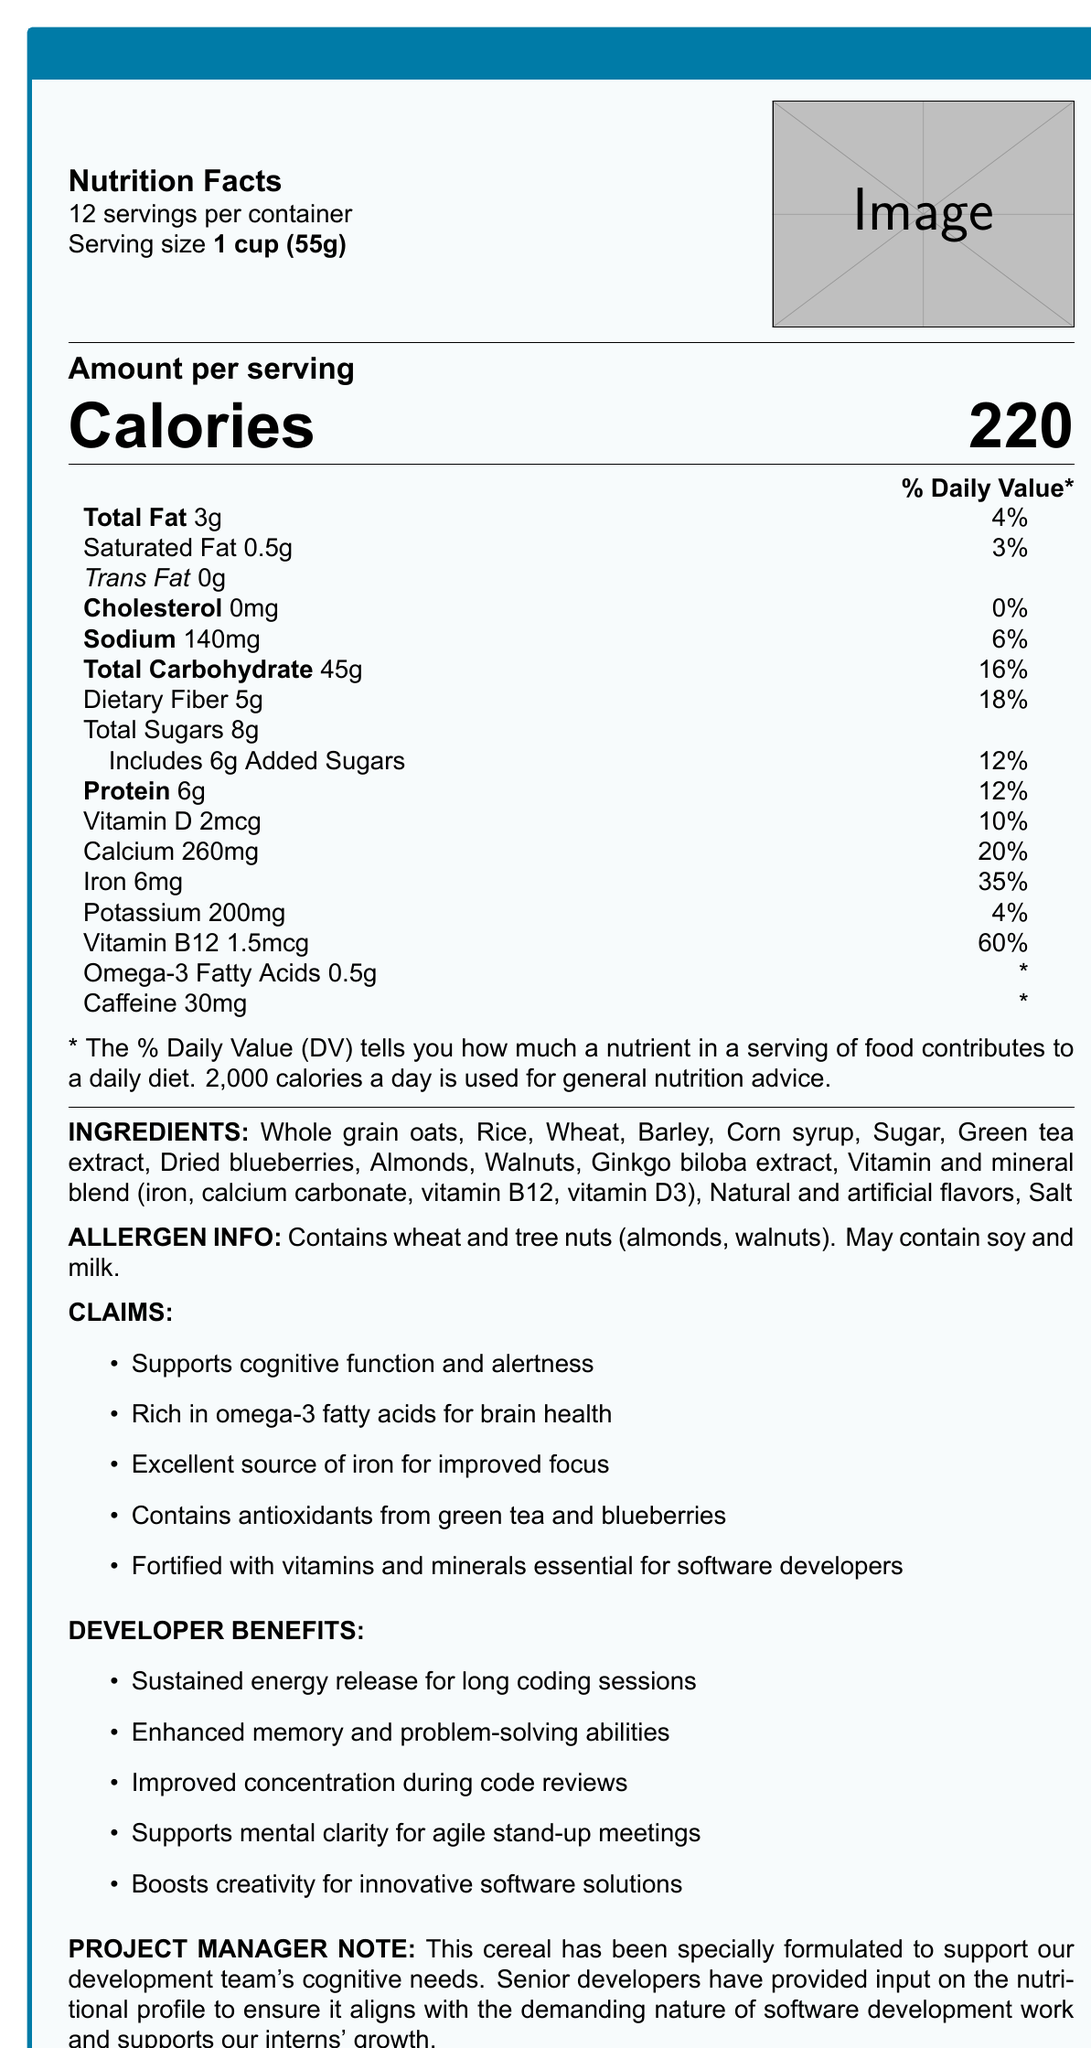What is the serving size of CodeCrunch cereal? The serving size is clearly indicated on the top left section of the nutrition facts as "Serving size 1 cup (55g)".
Answer: 1 cup (55g) How many servings are there per container? The document states "12 servings per container" right below the product name.
Answer: 12 What is the total amount of sugars per serving in the cereal? The total sugars per serving is listed as "Total Sugars 8g" in the nutrition facts.
Answer: 8g What percentage of the daily value of iron does one serving provide? The document states "Iron 6mg" with a "35%" daily value percentage.
Answer: 35% Which specific ingredient supports brain health through its omega-3 fatty acids? The ingredients list includes walnuts, which are known to be rich in omega-3 fatty acids.
Answer: Walnuts How many calories per serving does the CodeCrunch cereal contain? The document specifies "Calories 220" in the amount per serving section.
Answer: 220 What are the key cognitive benefits mentioned for software developers from consuming this cereal? The developer benefits section lists these specific cognitive benefits in bullet points.
Answer: Sustained energy release, enhanced memory and problem-solving abilities, improved concentration, supports mental clarity, boosts creativity What vitamin provides the highest percentage of daily value per serving in the cereal? A. Vitamin D B. Calcium C. Vitamin B12 D. Iron The document lists Vitamin B12 with a 60% daily value, which is higher than the other vitamins and minerals provided.
Answer: C. Vitamin B12 Which of the following ingredients is NOT mentioned in the cereal? 1. Almonds 2. Sunflower seeds 3. Green tea extract 4. Rice The ingredients list includes almonds, green tea extract, and rice, but there is no mention of sunflower seeds.
Answer: 2. Sunflower seeds Does the cereal contain any cholesterol? The nutrition facts state "Cholesterol 0mg" indicating that it does not contain cholesterol.
Answer: No Please summarize the main idea of this document. The document provides detailed information on the nutritional content, ingredients, health claims, and specific benefits for software developers, highlighting its design to support cognitive performance and overall well-being.
Answer: CodeCrunch: Brain-Boosting Breakfast Cereal is designed to support the cognitive and nutritional needs of software development teams with features like sustained energy, improved concentration, and enhanced memory. It contains a variety of ingredients, vitamins, and minerals tailored to benefit developers, with specific attention to brain health and cognitive function, and includes allergen information. What specific antioxidants are mentioned as being included in the cereal for cognitive support? The claims section lists "Contains antioxidants from green tea and blueberries" specifically for cognitive support.
Answer: Green tea and blueberries Can you determine the exact proportion of carbohydrates from sugars in one serving of the cereal from the document? The document provides the total carbohydrates (45g) and total sugars (8g), but does not break down other sources of carbohydrates to compute the exact proportion from sugars.
Answer: No 